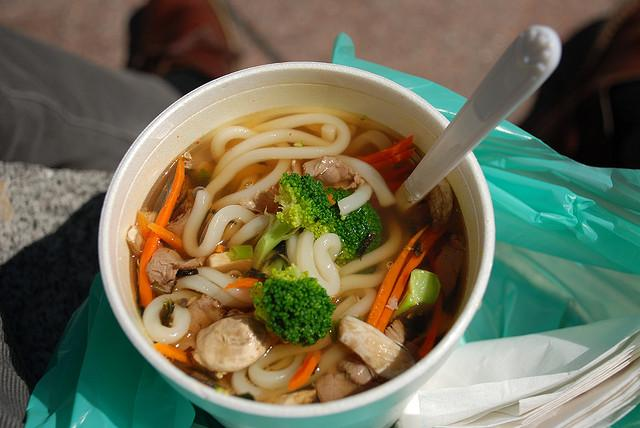What country do the noodles originate from? china 